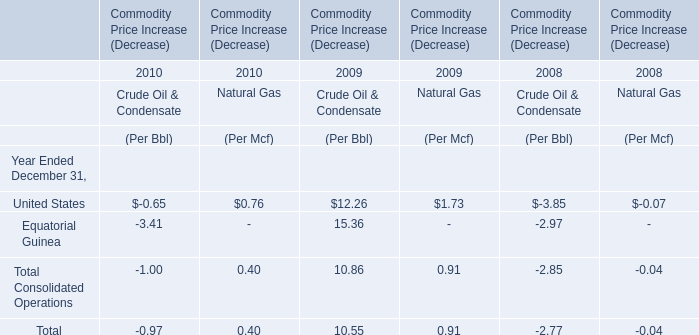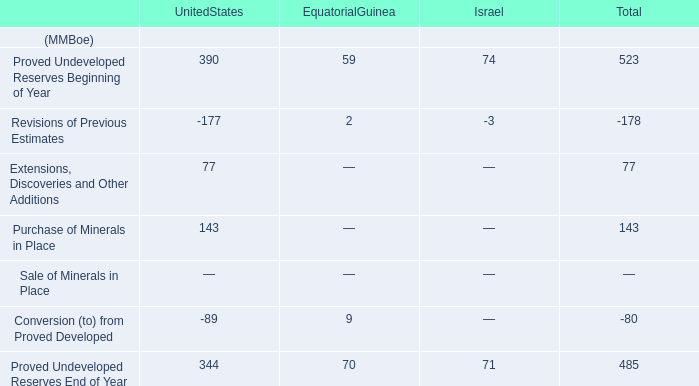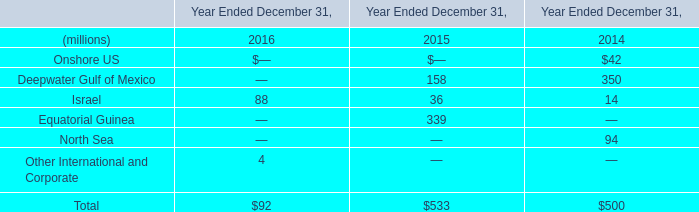In the year with higher amount of the Commodity Price Increase of Natural Gas totally, what's the amount of the Commodity Price Increase (Decrease) of Crude Oil & Condensate totally? 
Answer: 10.55. 